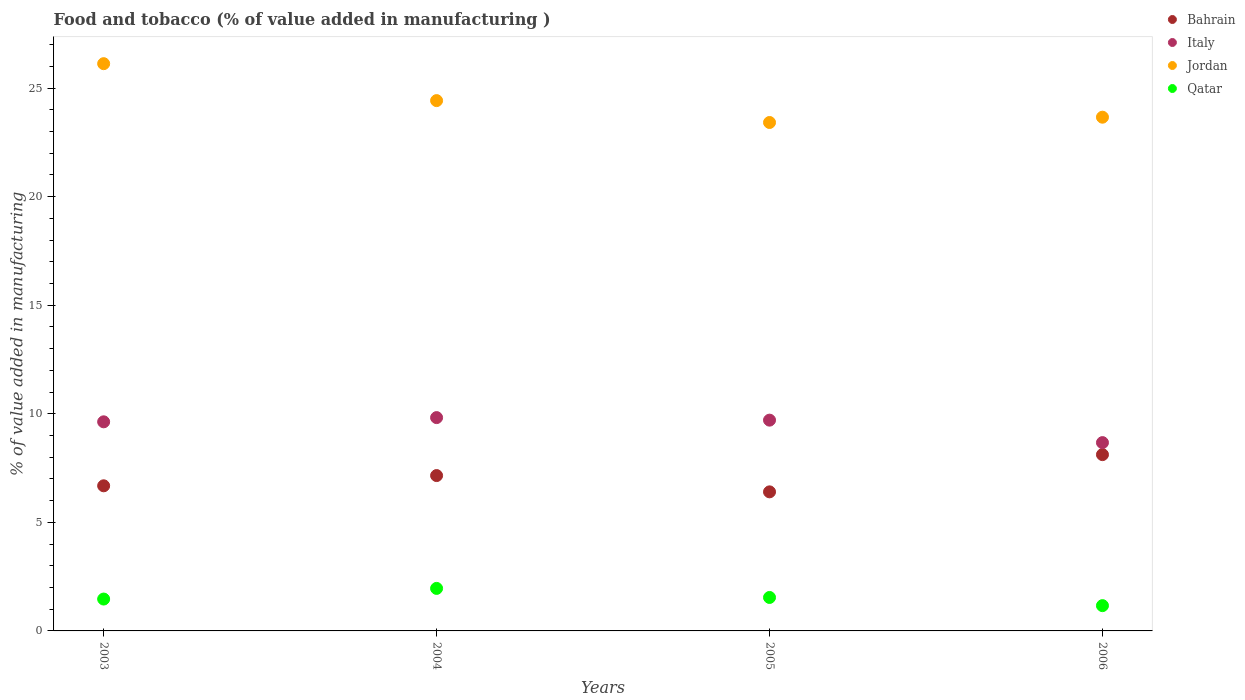How many different coloured dotlines are there?
Your response must be concise. 4. Is the number of dotlines equal to the number of legend labels?
Keep it short and to the point. Yes. What is the value added in manufacturing food and tobacco in Italy in 2004?
Your response must be concise. 9.83. Across all years, what is the maximum value added in manufacturing food and tobacco in Bahrain?
Make the answer very short. 8.12. Across all years, what is the minimum value added in manufacturing food and tobacco in Qatar?
Make the answer very short. 1.16. In which year was the value added in manufacturing food and tobacco in Italy maximum?
Give a very brief answer. 2004. What is the total value added in manufacturing food and tobacco in Qatar in the graph?
Keep it short and to the point. 6.13. What is the difference between the value added in manufacturing food and tobacco in Italy in 2004 and that in 2005?
Offer a very short reply. 0.12. What is the difference between the value added in manufacturing food and tobacco in Italy in 2006 and the value added in manufacturing food and tobacco in Jordan in 2004?
Your answer should be very brief. -15.75. What is the average value added in manufacturing food and tobacco in Bahrain per year?
Provide a short and direct response. 7.09. In the year 2005, what is the difference between the value added in manufacturing food and tobacco in Bahrain and value added in manufacturing food and tobacco in Jordan?
Give a very brief answer. -17.01. In how many years, is the value added in manufacturing food and tobacco in Qatar greater than 22 %?
Provide a short and direct response. 0. What is the ratio of the value added in manufacturing food and tobacco in Qatar in 2004 to that in 2005?
Your answer should be compact. 1.27. What is the difference between the highest and the second highest value added in manufacturing food and tobacco in Jordan?
Your answer should be very brief. 1.7. What is the difference between the highest and the lowest value added in manufacturing food and tobacco in Qatar?
Your response must be concise. 0.79. Is it the case that in every year, the sum of the value added in manufacturing food and tobacco in Bahrain and value added in manufacturing food and tobacco in Qatar  is greater than the sum of value added in manufacturing food and tobacco in Jordan and value added in manufacturing food and tobacco in Italy?
Provide a short and direct response. No. Does the value added in manufacturing food and tobacco in Bahrain monotonically increase over the years?
Your response must be concise. No. Is the value added in manufacturing food and tobacco in Qatar strictly greater than the value added in manufacturing food and tobacco in Jordan over the years?
Keep it short and to the point. No. How many dotlines are there?
Your answer should be compact. 4. How many years are there in the graph?
Offer a very short reply. 4. Does the graph contain any zero values?
Provide a short and direct response. No. How many legend labels are there?
Make the answer very short. 4. How are the legend labels stacked?
Give a very brief answer. Vertical. What is the title of the graph?
Your response must be concise. Food and tobacco (% of value added in manufacturing ). What is the label or title of the Y-axis?
Keep it short and to the point. % of value added in manufacturing. What is the % of value added in manufacturing in Bahrain in 2003?
Ensure brevity in your answer.  6.68. What is the % of value added in manufacturing of Italy in 2003?
Offer a terse response. 9.63. What is the % of value added in manufacturing of Jordan in 2003?
Provide a succinct answer. 26.13. What is the % of value added in manufacturing in Qatar in 2003?
Provide a short and direct response. 1.47. What is the % of value added in manufacturing of Bahrain in 2004?
Offer a terse response. 7.16. What is the % of value added in manufacturing of Italy in 2004?
Provide a short and direct response. 9.83. What is the % of value added in manufacturing in Jordan in 2004?
Keep it short and to the point. 24.43. What is the % of value added in manufacturing of Qatar in 2004?
Your answer should be compact. 1.96. What is the % of value added in manufacturing in Bahrain in 2005?
Offer a terse response. 6.41. What is the % of value added in manufacturing in Italy in 2005?
Your response must be concise. 9.71. What is the % of value added in manufacturing of Jordan in 2005?
Provide a short and direct response. 23.42. What is the % of value added in manufacturing in Qatar in 2005?
Your answer should be compact. 1.54. What is the % of value added in manufacturing of Bahrain in 2006?
Make the answer very short. 8.12. What is the % of value added in manufacturing in Italy in 2006?
Make the answer very short. 8.67. What is the % of value added in manufacturing in Jordan in 2006?
Give a very brief answer. 23.66. What is the % of value added in manufacturing in Qatar in 2006?
Ensure brevity in your answer.  1.16. Across all years, what is the maximum % of value added in manufacturing of Bahrain?
Keep it short and to the point. 8.12. Across all years, what is the maximum % of value added in manufacturing of Italy?
Your response must be concise. 9.83. Across all years, what is the maximum % of value added in manufacturing in Jordan?
Your response must be concise. 26.13. Across all years, what is the maximum % of value added in manufacturing of Qatar?
Ensure brevity in your answer.  1.96. Across all years, what is the minimum % of value added in manufacturing in Bahrain?
Provide a succinct answer. 6.41. Across all years, what is the minimum % of value added in manufacturing of Italy?
Offer a very short reply. 8.67. Across all years, what is the minimum % of value added in manufacturing of Jordan?
Provide a succinct answer. 23.42. Across all years, what is the minimum % of value added in manufacturing in Qatar?
Your answer should be very brief. 1.16. What is the total % of value added in manufacturing in Bahrain in the graph?
Your response must be concise. 28.36. What is the total % of value added in manufacturing of Italy in the graph?
Offer a terse response. 37.84. What is the total % of value added in manufacturing in Jordan in the graph?
Your response must be concise. 97.63. What is the total % of value added in manufacturing of Qatar in the graph?
Ensure brevity in your answer.  6.13. What is the difference between the % of value added in manufacturing in Bahrain in 2003 and that in 2004?
Offer a terse response. -0.47. What is the difference between the % of value added in manufacturing in Italy in 2003 and that in 2004?
Your answer should be compact. -0.19. What is the difference between the % of value added in manufacturing of Jordan in 2003 and that in 2004?
Your answer should be compact. 1.7. What is the difference between the % of value added in manufacturing of Qatar in 2003 and that in 2004?
Give a very brief answer. -0.49. What is the difference between the % of value added in manufacturing of Bahrain in 2003 and that in 2005?
Keep it short and to the point. 0.28. What is the difference between the % of value added in manufacturing of Italy in 2003 and that in 2005?
Provide a succinct answer. -0.08. What is the difference between the % of value added in manufacturing of Jordan in 2003 and that in 2005?
Offer a terse response. 2.71. What is the difference between the % of value added in manufacturing of Qatar in 2003 and that in 2005?
Make the answer very short. -0.07. What is the difference between the % of value added in manufacturing in Bahrain in 2003 and that in 2006?
Offer a terse response. -1.44. What is the difference between the % of value added in manufacturing in Italy in 2003 and that in 2006?
Make the answer very short. 0.96. What is the difference between the % of value added in manufacturing in Jordan in 2003 and that in 2006?
Offer a very short reply. 2.47. What is the difference between the % of value added in manufacturing of Qatar in 2003 and that in 2006?
Make the answer very short. 0.3. What is the difference between the % of value added in manufacturing of Bahrain in 2004 and that in 2005?
Ensure brevity in your answer.  0.75. What is the difference between the % of value added in manufacturing of Italy in 2004 and that in 2005?
Give a very brief answer. 0.12. What is the difference between the % of value added in manufacturing of Jordan in 2004 and that in 2005?
Offer a very short reply. 1.01. What is the difference between the % of value added in manufacturing in Qatar in 2004 and that in 2005?
Keep it short and to the point. 0.42. What is the difference between the % of value added in manufacturing in Bahrain in 2004 and that in 2006?
Your response must be concise. -0.96. What is the difference between the % of value added in manufacturing in Italy in 2004 and that in 2006?
Make the answer very short. 1.15. What is the difference between the % of value added in manufacturing in Jordan in 2004 and that in 2006?
Offer a terse response. 0.76. What is the difference between the % of value added in manufacturing in Qatar in 2004 and that in 2006?
Your response must be concise. 0.79. What is the difference between the % of value added in manufacturing in Bahrain in 2005 and that in 2006?
Provide a short and direct response. -1.71. What is the difference between the % of value added in manufacturing of Italy in 2005 and that in 2006?
Offer a terse response. 1.03. What is the difference between the % of value added in manufacturing of Jordan in 2005 and that in 2006?
Ensure brevity in your answer.  -0.24. What is the difference between the % of value added in manufacturing in Qatar in 2005 and that in 2006?
Your response must be concise. 0.38. What is the difference between the % of value added in manufacturing of Bahrain in 2003 and the % of value added in manufacturing of Italy in 2004?
Offer a very short reply. -3.14. What is the difference between the % of value added in manufacturing in Bahrain in 2003 and the % of value added in manufacturing in Jordan in 2004?
Ensure brevity in your answer.  -17.74. What is the difference between the % of value added in manufacturing in Bahrain in 2003 and the % of value added in manufacturing in Qatar in 2004?
Offer a very short reply. 4.73. What is the difference between the % of value added in manufacturing of Italy in 2003 and the % of value added in manufacturing of Jordan in 2004?
Give a very brief answer. -14.79. What is the difference between the % of value added in manufacturing in Italy in 2003 and the % of value added in manufacturing in Qatar in 2004?
Your answer should be compact. 7.67. What is the difference between the % of value added in manufacturing of Jordan in 2003 and the % of value added in manufacturing of Qatar in 2004?
Provide a succinct answer. 24.17. What is the difference between the % of value added in manufacturing in Bahrain in 2003 and the % of value added in manufacturing in Italy in 2005?
Offer a very short reply. -3.02. What is the difference between the % of value added in manufacturing in Bahrain in 2003 and the % of value added in manufacturing in Jordan in 2005?
Keep it short and to the point. -16.73. What is the difference between the % of value added in manufacturing in Bahrain in 2003 and the % of value added in manufacturing in Qatar in 2005?
Provide a short and direct response. 5.14. What is the difference between the % of value added in manufacturing of Italy in 2003 and the % of value added in manufacturing of Jordan in 2005?
Offer a terse response. -13.79. What is the difference between the % of value added in manufacturing in Italy in 2003 and the % of value added in manufacturing in Qatar in 2005?
Your answer should be compact. 8.09. What is the difference between the % of value added in manufacturing of Jordan in 2003 and the % of value added in manufacturing of Qatar in 2005?
Give a very brief answer. 24.59. What is the difference between the % of value added in manufacturing in Bahrain in 2003 and the % of value added in manufacturing in Italy in 2006?
Provide a short and direct response. -1.99. What is the difference between the % of value added in manufacturing of Bahrain in 2003 and the % of value added in manufacturing of Jordan in 2006?
Keep it short and to the point. -16.98. What is the difference between the % of value added in manufacturing in Bahrain in 2003 and the % of value added in manufacturing in Qatar in 2006?
Ensure brevity in your answer.  5.52. What is the difference between the % of value added in manufacturing of Italy in 2003 and the % of value added in manufacturing of Jordan in 2006?
Your answer should be compact. -14.03. What is the difference between the % of value added in manufacturing in Italy in 2003 and the % of value added in manufacturing in Qatar in 2006?
Provide a succinct answer. 8.47. What is the difference between the % of value added in manufacturing in Jordan in 2003 and the % of value added in manufacturing in Qatar in 2006?
Keep it short and to the point. 24.96. What is the difference between the % of value added in manufacturing in Bahrain in 2004 and the % of value added in manufacturing in Italy in 2005?
Your response must be concise. -2.55. What is the difference between the % of value added in manufacturing of Bahrain in 2004 and the % of value added in manufacturing of Jordan in 2005?
Offer a very short reply. -16.26. What is the difference between the % of value added in manufacturing in Bahrain in 2004 and the % of value added in manufacturing in Qatar in 2005?
Ensure brevity in your answer.  5.61. What is the difference between the % of value added in manufacturing in Italy in 2004 and the % of value added in manufacturing in Jordan in 2005?
Your response must be concise. -13.59. What is the difference between the % of value added in manufacturing of Italy in 2004 and the % of value added in manufacturing of Qatar in 2005?
Give a very brief answer. 8.28. What is the difference between the % of value added in manufacturing of Jordan in 2004 and the % of value added in manufacturing of Qatar in 2005?
Give a very brief answer. 22.88. What is the difference between the % of value added in manufacturing of Bahrain in 2004 and the % of value added in manufacturing of Italy in 2006?
Provide a short and direct response. -1.52. What is the difference between the % of value added in manufacturing of Bahrain in 2004 and the % of value added in manufacturing of Jordan in 2006?
Provide a succinct answer. -16.51. What is the difference between the % of value added in manufacturing in Bahrain in 2004 and the % of value added in manufacturing in Qatar in 2006?
Ensure brevity in your answer.  5.99. What is the difference between the % of value added in manufacturing in Italy in 2004 and the % of value added in manufacturing in Jordan in 2006?
Offer a terse response. -13.84. What is the difference between the % of value added in manufacturing of Italy in 2004 and the % of value added in manufacturing of Qatar in 2006?
Provide a succinct answer. 8.66. What is the difference between the % of value added in manufacturing in Jordan in 2004 and the % of value added in manufacturing in Qatar in 2006?
Make the answer very short. 23.26. What is the difference between the % of value added in manufacturing of Bahrain in 2005 and the % of value added in manufacturing of Italy in 2006?
Your answer should be compact. -2.27. What is the difference between the % of value added in manufacturing in Bahrain in 2005 and the % of value added in manufacturing in Jordan in 2006?
Your response must be concise. -17.26. What is the difference between the % of value added in manufacturing of Bahrain in 2005 and the % of value added in manufacturing of Qatar in 2006?
Make the answer very short. 5.24. What is the difference between the % of value added in manufacturing of Italy in 2005 and the % of value added in manufacturing of Jordan in 2006?
Keep it short and to the point. -13.95. What is the difference between the % of value added in manufacturing of Italy in 2005 and the % of value added in manufacturing of Qatar in 2006?
Ensure brevity in your answer.  8.54. What is the difference between the % of value added in manufacturing in Jordan in 2005 and the % of value added in manufacturing in Qatar in 2006?
Provide a short and direct response. 22.25. What is the average % of value added in manufacturing of Bahrain per year?
Provide a short and direct response. 7.09. What is the average % of value added in manufacturing in Italy per year?
Your answer should be very brief. 9.46. What is the average % of value added in manufacturing of Jordan per year?
Provide a short and direct response. 24.41. What is the average % of value added in manufacturing of Qatar per year?
Give a very brief answer. 1.53. In the year 2003, what is the difference between the % of value added in manufacturing in Bahrain and % of value added in manufacturing in Italy?
Your response must be concise. -2.95. In the year 2003, what is the difference between the % of value added in manufacturing in Bahrain and % of value added in manufacturing in Jordan?
Keep it short and to the point. -19.44. In the year 2003, what is the difference between the % of value added in manufacturing in Bahrain and % of value added in manufacturing in Qatar?
Ensure brevity in your answer.  5.22. In the year 2003, what is the difference between the % of value added in manufacturing in Italy and % of value added in manufacturing in Jordan?
Offer a terse response. -16.5. In the year 2003, what is the difference between the % of value added in manufacturing of Italy and % of value added in manufacturing of Qatar?
Your answer should be very brief. 8.16. In the year 2003, what is the difference between the % of value added in manufacturing of Jordan and % of value added in manufacturing of Qatar?
Provide a succinct answer. 24.66. In the year 2004, what is the difference between the % of value added in manufacturing in Bahrain and % of value added in manufacturing in Italy?
Provide a short and direct response. -2.67. In the year 2004, what is the difference between the % of value added in manufacturing of Bahrain and % of value added in manufacturing of Jordan?
Provide a succinct answer. -17.27. In the year 2004, what is the difference between the % of value added in manufacturing in Bahrain and % of value added in manufacturing in Qatar?
Make the answer very short. 5.2. In the year 2004, what is the difference between the % of value added in manufacturing in Italy and % of value added in manufacturing in Jordan?
Keep it short and to the point. -14.6. In the year 2004, what is the difference between the % of value added in manufacturing of Italy and % of value added in manufacturing of Qatar?
Offer a terse response. 7.87. In the year 2004, what is the difference between the % of value added in manufacturing in Jordan and % of value added in manufacturing in Qatar?
Your answer should be very brief. 22.47. In the year 2005, what is the difference between the % of value added in manufacturing of Bahrain and % of value added in manufacturing of Italy?
Provide a succinct answer. -3.3. In the year 2005, what is the difference between the % of value added in manufacturing in Bahrain and % of value added in manufacturing in Jordan?
Provide a short and direct response. -17.01. In the year 2005, what is the difference between the % of value added in manufacturing of Bahrain and % of value added in manufacturing of Qatar?
Provide a succinct answer. 4.86. In the year 2005, what is the difference between the % of value added in manufacturing of Italy and % of value added in manufacturing of Jordan?
Keep it short and to the point. -13.71. In the year 2005, what is the difference between the % of value added in manufacturing of Italy and % of value added in manufacturing of Qatar?
Offer a very short reply. 8.17. In the year 2005, what is the difference between the % of value added in manufacturing in Jordan and % of value added in manufacturing in Qatar?
Offer a terse response. 21.88. In the year 2006, what is the difference between the % of value added in manufacturing in Bahrain and % of value added in manufacturing in Italy?
Your answer should be very brief. -0.55. In the year 2006, what is the difference between the % of value added in manufacturing in Bahrain and % of value added in manufacturing in Jordan?
Give a very brief answer. -15.54. In the year 2006, what is the difference between the % of value added in manufacturing in Bahrain and % of value added in manufacturing in Qatar?
Offer a very short reply. 6.96. In the year 2006, what is the difference between the % of value added in manufacturing of Italy and % of value added in manufacturing of Jordan?
Provide a short and direct response. -14.99. In the year 2006, what is the difference between the % of value added in manufacturing in Italy and % of value added in manufacturing in Qatar?
Provide a succinct answer. 7.51. In the year 2006, what is the difference between the % of value added in manufacturing of Jordan and % of value added in manufacturing of Qatar?
Your response must be concise. 22.5. What is the ratio of the % of value added in manufacturing in Bahrain in 2003 to that in 2004?
Offer a very short reply. 0.93. What is the ratio of the % of value added in manufacturing in Italy in 2003 to that in 2004?
Keep it short and to the point. 0.98. What is the ratio of the % of value added in manufacturing of Jordan in 2003 to that in 2004?
Your response must be concise. 1.07. What is the ratio of the % of value added in manufacturing of Qatar in 2003 to that in 2004?
Give a very brief answer. 0.75. What is the ratio of the % of value added in manufacturing in Bahrain in 2003 to that in 2005?
Your response must be concise. 1.04. What is the ratio of the % of value added in manufacturing in Jordan in 2003 to that in 2005?
Keep it short and to the point. 1.12. What is the ratio of the % of value added in manufacturing in Qatar in 2003 to that in 2005?
Your answer should be very brief. 0.95. What is the ratio of the % of value added in manufacturing in Bahrain in 2003 to that in 2006?
Your answer should be very brief. 0.82. What is the ratio of the % of value added in manufacturing of Italy in 2003 to that in 2006?
Your response must be concise. 1.11. What is the ratio of the % of value added in manufacturing of Jordan in 2003 to that in 2006?
Make the answer very short. 1.1. What is the ratio of the % of value added in manufacturing of Qatar in 2003 to that in 2006?
Your response must be concise. 1.26. What is the ratio of the % of value added in manufacturing of Bahrain in 2004 to that in 2005?
Your answer should be compact. 1.12. What is the ratio of the % of value added in manufacturing in Italy in 2004 to that in 2005?
Offer a very short reply. 1.01. What is the ratio of the % of value added in manufacturing in Jordan in 2004 to that in 2005?
Ensure brevity in your answer.  1.04. What is the ratio of the % of value added in manufacturing of Qatar in 2004 to that in 2005?
Give a very brief answer. 1.27. What is the ratio of the % of value added in manufacturing in Bahrain in 2004 to that in 2006?
Your answer should be very brief. 0.88. What is the ratio of the % of value added in manufacturing in Italy in 2004 to that in 2006?
Provide a short and direct response. 1.13. What is the ratio of the % of value added in manufacturing in Jordan in 2004 to that in 2006?
Keep it short and to the point. 1.03. What is the ratio of the % of value added in manufacturing in Qatar in 2004 to that in 2006?
Your answer should be very brief. 1.68. What is the ratio of the % of value added in manufacturing of Bahrain in 2005 to that in 2006?
Your answer should be very brief. 0.79. What is the ratio of the % of value added in manufacturing in Italy in 2005 to that in 2006?
Your answer should be very brief. 1.12. What is the ratio of the % of value added in manufacturing of Qatar in 2005 to that in 2006?
Keep it short and to the point. 1.32. What is the difference between the highest and the second highest % of value added in manufacturing in Bahrain?
Keep it short and to the point. 0.96. What is the difference between the highest and the second highest % of value added in manufacturing of Italy?
Your answer should be very brief. 0.12. What is the difference between the highest and the second highest % of value added in manufacturing of Jordan?
Make the answer very short. 1.7. What is the difference between the highest and the second highest % of value added in manufacturing in Qatar?
Your response must be concise. 0.42. What is the difference between the highest and the lowest % of value added in manufacturing in Bahrain?
Your answer should be compact. 1.71. What is the difference between the highest and the lowest % of value added in manufacturing in Italy?
Ensure brevity in your answer.  1.15. What is the difference between the highest and the lowest % of value added in manufacturing of Jordan?
Offer a terse response. 2.71. What is the difference between the highest and the lowest % of value added in manufacturing of Qatar?
Offer a very short reply. 0.79. 